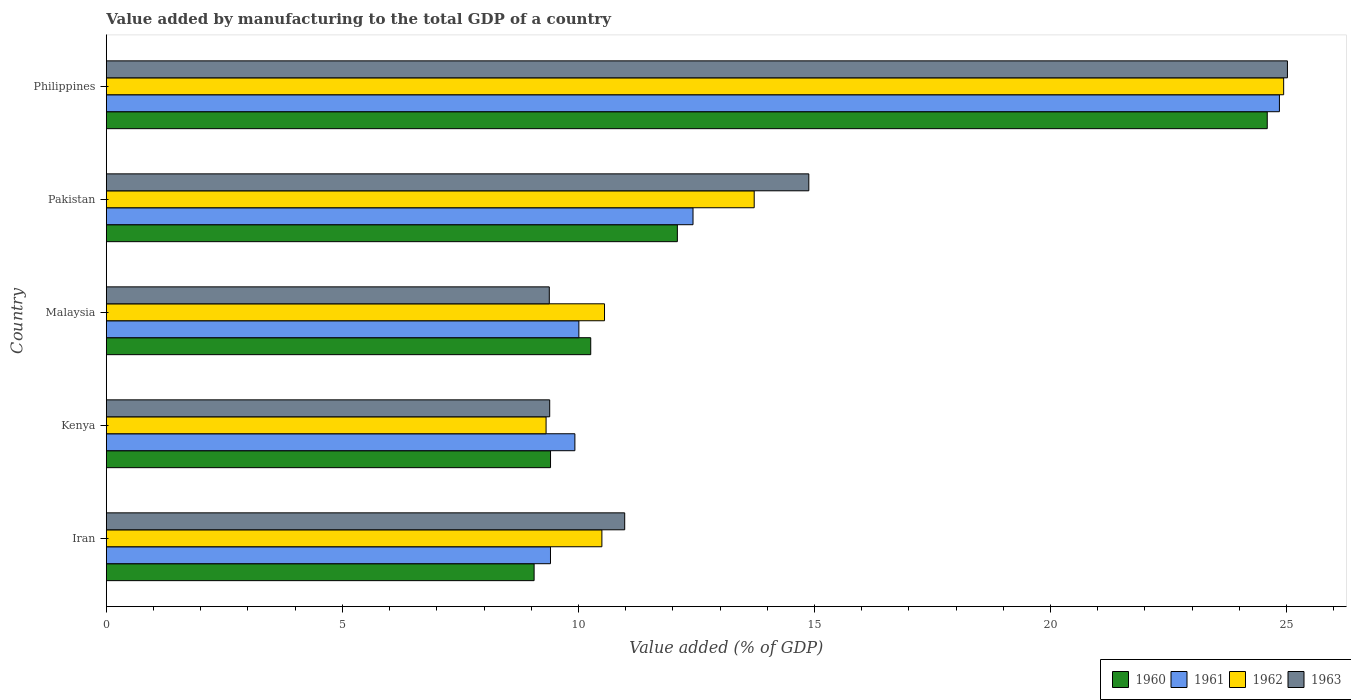How many different coloured bars are there?
Offer a very short reply. 4. How many groups of bars are there?
Your answer should be very brief. 5. Are the number of bars per tick equal to the number of legend labels?
Provide a succinct answer. Yes. How many bars are there on the 1st tick from the bottom?
Give a very brief answer. 4. What is the label of the 5th group of bars from the top?
Give a very brief answer. Iran. In how many cases, is the number of bars for a given country not equal to the number of legend labels?
Give a very brief answer. 0. What is the value added by manufacturing to the total GDP in 1963 in Malaysia?
Offer a very short reply. 9.38. Across all countries, what is the maximum value added by manufacturing to the total GDP in 1963?
Keep it short and to the point. 25.02. Across all countries, what is the minimum value added by manufacturing to the total GDP in 1960?
Offer a terse response. 9.06. In which country was the value added by manufacturing to the total GDP in 1960 maximum?
Give a very brief answer. Philippines. In which country was the value added by manufacturing to the total GDP in 1960 minimum?
Keep it short and to the point. Iran. What is the total value added by manufacturing to the total GDP in 1960 in the graph?
Your response must be concise. 65.42. What is the difference between the value added by manufacturing to the total GDP in 1960 in Kenya and that in Malaysia?
Your answer should be very brief. -0.85. What is the difference between the value added by manufacturing to the total GDP in 1961 in Kenya and the value added by manufacturing to the total GDP in 1962 in Pakistan?
Keep it short and to the point. -3.8. What is the average value added by manufacturing to the total GDP in 1960 per country?
Your response must be concise. 13.08. What is the difference between the value added by manufacturing to the total GDP in 1961 and value added by manufacturing to the total GDP in 1962 in Malaysia?
Your answer should be compact. -0.54. In how many countries, is the value added by manufacturing to the total GDP in 1963 greater than 20 %?
Your answer should be compact. 1. What is the ratio of the value added by manufacturing to the total GDP in 1963 in Iran to that in Pakistan?
Offer a very short reply. 0.74. What is the difference between the highest and the second highest value added by manufacturing to the total GDP in 1962?
Provide a short and direct response. 11.22. What is the difference between the highest and the lowest value added by manufacturing to the total GDP in 1960?
Offer a terse response. 15.53. What does the 2nd bar from the top in Iran represents?
Your answer should be very brief. 1962. What does the 2nd bar from the bottom in Kenya represents?
Your answer should be compact. 1961. Is it the case that in every country, the sum of the value added by manufacturing to the total GDP in 1960 and value added by manufacturing to the total GDP in 1962 is greater than the value added by manufacturing to the total GDP in 1963?
Give a very brief answer. Yes. How many bars are there?
Keep it short and to the point. 20. Are the values on the major ticks of X-axis written in scientific E-notation?
Keep it short and to the point. No. Does the graph contain any zero values?
Give a very brief answer. No. Does the graph contain grids?
Ensure brevity in your answer.  No. Where does the legend appear in the graph?
Provide a succinct answer. Bottom right. How many legend labels are there?
Offer a terse response. 4. What is the title of the graph?
Ensure brevity in your answer.  Value added by manufacturing to the total GDP of a country. What is the label or title of the X-axis?
Provide a short and direct response. Value added (% of GDP). What is the Value added (% of GDP) in 1960 in Iran?
Make the answer very short. 9.06. What is the Value added (% of GDP) of 1961 in Iran?
Your answer should be compact. 9.41. What is the Value added (% of GDP) of 1962 in Iran?
Your response must be concise. 10.5. What is the Value added (% of GDP) of 1963 in Iran?
Make the answer very short. 10.98. What is the Value added (% of GDP) in 1960 in Kenya?
Your answer should be compact. 9.41. What is the Value added (% of GDP) of 1961 in Kenya?
Your answer should be compact. 9.93. What is the Value added (% of GDP) of 1962 in Kenya?
Keep it short and to the point. 9.32. What is the Value added (% of GDP) of 1963 in Kenya?
Provide a short and direct response. 9.39. What is the Value added (% of GDP) of 1960 in Malaysia?
Give a very brief answer. 10.26. What is the Value added (% of GDP) of 1961 in Malaysia?
Provide a succinct answer. 10.01. What is the Value added (% of GDP) in 1962 in Malaysia?
Make the answer very short. 10.55. What is the Value added (% of GDP) of 1963 in Malaysia?
Provide a succinct answer. 9.38. What is the Value added (% of GDP) in 1960 in Pakistan?
Give a very brief answer. 12.1. What is the Value added (% of GDP) in 1961 in Pakistan?
Your response must be concise. 12.43. What is the Value added (% of GDP) of 1962 in Pakistan?
Offer a very short reply. 13.72. What is the Value added (% of GDP) in 1963 in Pakistan?
Your answer should be very brief. 14.88. What is the Value added (% of GDP) in 1960 in Philippines?
Your answer should be compact. 24.59. What is the Value added (% of GDP) of 1961 in Philippines?
Provide a succinct answer. 24.85. What is the Value added (% of GDP) of 1962 in Philippines?
Your response must be concise. 24.94. What is the Value added (% of GDP) of 1963 in Philippines?
Make the answer very short. 25.02. Across all countries, what is the maximum Value added (% of GDP) of 1960?
Make the answer very short. 24.59. Across all countries, what is the maximum Value added (% of GDP) of 1961?
Keep it short and to the point. 24.85. Across all countries, what is the maximum Value added (% of GDP) of 1962?
Offer a terse response. 24.94. Across all countries, what is the maximum Value added (% of GDP) in 1963?
Your answer should be compact. 25.02. Across all countries, what is the minimum Value added (% of GDP) of 1960?
Offer a terse response. 9.06. Across all countries, what is the minimum Value added (% of GDP) in 1961?
Your response must be concise. 9.41. Across all countries, what is the minimum Value added (% of GDP) in 1962?
Offer a very short reply. 9.32. Across all countries, what is the minimum Value added (% of GDP) of 1963?
Offer a very short reply. 9.38. What is the total Value added (% of GDP) in 1960 in the graph?
Give a very brief answer. 65.42. What is the total Value added (% of GDP) in 1961 in the graph?
Your response must be concise. 66.62. What is the total Value added (% of GDP) of 1962 in the graph?
Ensure brevity in your answer.  69.03. What is the total Value added (% of GDP) in 1963 in the graph?
Your answer should be very brief. 69.66. What is the difference between the Value added (% of GDP) in 1960 in Iran and that in Kenya?
Keep it short and to the point. -0.35. What is the difference between the Value added (% of GDP) in 1961 in Iran and that in Kenya?
Your answer should be very brief. -0.52. What is the difference between the Value added (% of GDP) in 1962 in Iran and that in Kenya?
Make the answer very short. 1.18. What is the difference between the Value added (% of GDP) in 1963 in Iran and that in Kenya?
Keep it short and to the point. 1.59. What is the difference between the Value added (% of GDP) of 1960 in Iran and that in Malaysia?
Provide a succinct answer. -1.2. What is the difference between the Value added (% of GDP) of 1961 in Iran and that in Malaysia?
Keep it short and to the point. -0.6. What is the difference between the Value added (% of GDP) in 1962 in Iran and that in Malaysia?
Your answer should be compact. -0.06. What is the difference between the Value added (% of GDP) in 1963 in Iran and that in Malaysia?
Your answer should be compact. 1.6. What is the difference between the Value added (% of GDP) of 1960 in Iran and that in Pakistan?
Offer a very short reply. -3.03. What is the difference between the Value added (% of GDP) in 1961 in Iran and that in Pakistan?
Provide a short and direct response. -3.02. What is the difference between the Value added (% of GDP) in 1962 in Iran and that in Pakistan?
Ensure brevity in your answer.  -3.23. What is the difference between the Value added (% of GDP) in 1963 in Iran and that in Pakistan?
Provide a short and direct response. -3.9. What is the difference between the Value added (% of GDP) in 1960 in Iran and that in Philippines?
Give a very brief answer. -15.53. What is the difference between the Value added (% of GDP) of 1961 in Iran and that in Philippines?
Your answer should be very brief. -15.44. What is the difference between the Value added (% of GDP) of 1962 in Iran and that in Philippines?
Ensure brevity in your answer.  -14.44. What is the difference between the Value added (% of GDP) of 1963 in Iran and that in Philippines?
Keep it short and to the point. -14.04. What is the difference between the Value added (% of GDP) in 1960 in Kenya and that in Malaysia?
Your answer should be very brief. -0.85. What is the difference between the Value added (% of GDP) in 1961 in Kenya and that in Malaysia?
Offer a very short reply. -0.08. What is the difference between the Value added (% of GDP) in 1962 in Kenya and that in Malaysia?
Keep it short and to the point. -1.24. What is the difference between the Value added (% of GDP) in 1963 in Kenya and that in Malaysia?
Ensure brevity in your answer.  0.01. What is the difference between the Value added (% of GDP) of 1960 in Kenya and that in Pakistan?
Keep it short and to the point. -2.69. What is the difference between the Value added (% of GDP) of 1961 in Kenya and that in Pakistan?
Offer a terse response. -2.5. What is the difference between the Value added (% of GDP) of 1962 in Kenya and that in Pakistan?
Provide a succinct answer. -4.41. What is the difference between the Value added (% of GDP) of 1963 in Kenya and that in Pakistan?
Offer a terse response. -5.49. What is the difference between the Value added (% of GDP) of 1960 in Kenya and that in Philippines?
Offer a terse response. -15.18. What is the difference between the Value added (% of GDP) of 1961 in Kenya and that in Philippines?
Provide a short and direct response. -14.92. What is the difference between the Value added (% of GDP) in 1962 in Kenya and that in Philippines?
Your response must be concise. -15.62. What is the difference between the Value added (% of GDP) of 1963 in Kenya and that in Philippines?
Offer a terse response. -15.63. What is the difference between the Value added (% of GDP) of 1960 in Malaysia and that in Pakistan?
Provide a succinct answer. -1.84. What is the difference between the Value added (% of GDP) of 1961 in Malaysia and that in Pakistan?
Your answer should be compact. -2.42. What is the difference between the Value added (% of GDP) in 1962 in Malaysia and that in Pakistan?
Ensure brevity in your answer.  -3.17. What is the difference between the Value added (% of GDP) in 1963 in Malaysia and that in Pakistan?
Provide a succinct answer. -5.5. What is the difference between the Value added (% of GDP) of 1960 in Malaysia and that in Philippines?
Your response must be concise. -14.33. What is the difference between the Value added (% of GDP) of 1961 in Malaysia and that in Philippines?
Your answer should be very brief. -14.84. What is the difference between the Value added (% of GDP) in 1962 in Malaysia and that in Philippines?
Your answer should be compact. -14.39. What is the difference between the Value added (% of GDP) in 1963 in Malaysia and that in Philippines?
Your answer should be compact. -15.64. What is the difference between the Value added (% of GDP) in 1960 in Pakistan and that in Philippines?
Provide a succinct answer. -12.5. What is the difference between the Value added (% of GDP) in 1961 in Pakistan and that in Philippines?
Offer a very short reply. -12.42. What is the difference between the Value added (% of GDP) in 1962 in Pakistan and that in Philippines?
Provide a succinct answer. -11.22. What is the difference between the Value added (% of GDP) in 1963 in Pakistan and that in Philippines?
Ensure brevity in your answer.  -10.14. What is the difference between the Value added (% of GDP) in 1960 in Iran and the Value added (% of GDP) in 1961 in Kenya?
Offer a terse response. -0.86. What is the difference between the Value added (% of GDP) in 1960 in Iran and the Value added (% of GDP) in 1962 in Kenya?
Ensure brevity in your answer.  -0.25. What is the difference between the Value added (% of GDP) of 1960 in Iran and the Value added (% of GDP) of 1963 in Kenya?
Ensure brevity in your answer.  -0.33. What is the difference between the Value added (% of GDP) of 1961 in Iran and the Value added (% of GDP) of 1962 in Kenya?
Ensure brevity in your answer.  0.09. What is the difference between the Value added (% of GDP) of 1961 in Iran and the Value added (% of GDP) of 1963 in Kenya?
Make the answer very short. 0.02. What is the difference between the Value added (% of GDP) in 1962 in Iran and the Value added (% of GDP) in 1963 in Kenya?
Your response must be concise. 1.11. What is the difference between the Value added (% of GDP) in 1960 in Iran and the Value added (% of GDP) in 1961 in Malaysia?
Ensure brevity in your answer.  -0.95. What is the difference between the Value added (% of GDP) of 1960 in Iran and the Value added (% of GDP) of 1962 in Malaysia?
Provide a succinct answer. -1.49. What is the difference between the Value added (% of GDP) of 1960 in Iran and the Value added (% of GDP) of 1963 in Malaysia?
Offer a terse response. -0.32. What is the difference between the Value added (% of GDP) in 1961 in Iran and the Value added (% of GDP) in 1962 in Malaysia?
Your answer should be very brief. -1.14. What is the difference between the Value added (% of GDP) in 1961 in Iran and the Value added (% of GDP) in 1963 in Malaysia?
Provide a succinct answer. 0.03. What is the difference between the Value added (% of GDP) in 1962 in Iran and the Value added (% of GDP) in 1963 in Malaysia?
Your answer should be compact. 1.11. What is the difference between the Value added (% of GDP) in 1960 in Iran and the Value added (% of GDP) in 1961 in Pakistan?
Ensure brevity in your answer.  -3.37. What is the difference between the Value added (% of GDP) of 1960 in Iran and the Value added (% of GDP) of 1962 in Pakistan?
Provide a succinct answer. -4.66. What is the difference between the Value added (% of GDP) of 1960 in Iran and the Value added (% of GDP) of 1963 in Pakistan?
Provide a succinct answer. -5.82. What is the difference between the Value added (% of GDP) of 1961 in Iran and the Value added (% of GDP) of 1962 in Pakistan?
Provide a short and direct response. -4.32. What is the difference between the Value added (% of GDP) in 1961 in Iran and the Value added (% of GDP) in 1963 in Pakistan?
Your response must be concise. -5.47. What is the difference between the Value added (% of GDP) of 1962 in Iran and the Value added (% of GDP) of 1963 in Pakistan?
Make the answer very short. -4.38. What is the difference between the Value added (% of GDP) of 1960 in Iran and the Value added (% of GDP) of 1961 in Philippines?
Keep it short and to the point. -15.79. What is the difference between the Value added (% of GDP) of 1960 in Iran and the Value added (% of GDP) of 1962 in Philippines?
Your answer should be very brief. -15.88. What is the difference between the Value added (% of GDP) of 1960 in Iran and the Value added (% of GDP) of 1963 in Philippines?
Ensure brevity in your answer.  -15.96. What is the difference between the Value added (% of GDP) in 1961 in Iran and the Value added (% of GDP) in 1962 in Philippines?
Your answer should be compact. -15.53. What is the difference between the Value added (% of GDP) in 1961 in Iran and the Value added (% of GDP) in 1963 in Philippines?
Provide a short and direct response. -15.61. What is the difference between the Value added (% of GDP) of 1962 in Iran and the Value added (% of GDP) of 1963 in Philippines?
Keep it short and to the point. -14.52. What is the difference between the Value added (% of GDP) of 1960 in Kenya and the Value added (% of GDP) of 1961 in Malaysia?
Offer a very short reply. -0.6. What is the difference between the Value added (% of GDP) in 1960 in Kenya and the Value added (% of GDP) in 1962 in Malaysia?
Offer a terse response. -1.14. What is the difference between the Value added (% of GDP) of 1960 in Kenya and the Value added (% of GDP) of 1963 in Malaysia?
Your answer should be compact. 0.03. What is the difference between the Value added (% of GDP) of 1961 in Kenya and the Value added (% of GDP) of 1962 in Malaysia?
Provide a short and direct response. -0.63. What is the difference between the Value added (% of GDP) in 1961 in Kenya and the Value added (% of GDP) in 1963 in Malaysia?
Your response must be concise. 0.54. What is the difference between the Value added (% of GDP) of 1962 in Kenya and the Value added (% of GDP) of 1963 in Malaysia?
Give a very brief answer. -0.07. What is the difference between the Value added (% of GDP) in 1960 in Kenya and the Value added (% of GDP) in 1961 in Pakistan?
Give a very brief answer. -3.02. What is the difference between the Value added (% of GDP) of 1960 in Kenya and the Value added (% of GDP) of 1962 in Pakistan?
Offer a terse response. -4.31. What is the difference between the Value added (% of GDP) of 1960 in Kenya and the Value added (% of GDP) of 1963 in Pakistan?
Provide a short and direct response. -5.47. What is the difference between the Value added (% of GDP) in 1961 in Kenya and the Value added (% of GDP) in 1962 in Pakistan?
Your response must be concise. -3.8. What is the difference between the Value added (% of GDP) in 1961 in Kenya and the Value added (% of GDP) in 1963 in Pakistan?
Your response must be concise. -4.96. What is the difference between the Value added (% of GDP) in 1962 in Kenya and the Value added (% of GDP) in 1963 in Pakistan?
Provide a short and direct response. -5.57. What is the difference between the Value added (% of GDP) of 1960 in Kenya and the Value added (% of GDP) of 1961 in Philippines?
Your answer should be very brief. -15.44. What is the difference between the Value added (% of GDP) of 1960 in Kenya and the Value added (% of GDP) of 1962 in Philippines?
Give a very brief answer. -15.53. What is the difference between the Value added (% of GDP) of 1960 in Kenya and the Value added (% of GDP) of 1963 in Philippines?
Make the answer very short. -15.61. What is the difference between the Value added (% of GDP) of 1961 in Kenya and the Value added (% of GDP) of 1962 in Philippines?
Make the answer very short. -15.01. What is the difference between the Value added (% of GDP) of 1961 in Kenya and the Value added (% of GDP) of 1963 in Philippines?
Your response must be concise. -15.09. What is the difference between the Value added (% of GDP) of 1962 in Kenya and the Value added (% of GDP) of 1963 in Philippines?
Provide a short and direct response. -15.7. What is the difference between the Value added (% of GDP) in 1960 in Malaysia and the Value added (% of GDP) in 1961 in Pakistan?
Provide a short and direct response. -2.17. What is the difference between the Value added (% of GDP) in 1960 in Malaysia and the Value added (% of GDP) in 1962 in Pakistan?
Ensure brevity in your answer.  -3.46. What is the difference between the Value added (% of GDP) in 1960 in Malaysia and the Value added (% of GDP) in 1963 in Pakistan?
Keep it short and to the point. -4.62. What is the difference between the Value added (% of GDP) of 1961 in Malaysia and the Value added (% of GDP) of 1962 in Pakistan?
Give a very brief answer. -3.71. What is the difference between the Value added (% of GDP) of 1961 in Malaysia and the Value added (% of GDP) of 1963 in Pakistan?
Provide a short and direct response. -4.87. What is the difference between the Value added (% of GDP) of 1962 in Malaysia and the Value added (% of GDP) of 1963 in Pakistan?
Provide a succinct answer. -4.33. What is the difference between the Value added (% of GDP) in 1960 in Malaysia and the Value added (% of GDP) in 1961 in Philippines?
Give a very brief answer. -14.59. What is the difference between the Value added (% of GDP) of 1960 in Malaysia and the Value added (% of GDP) of 1962 in Philippines?
Provide a short and direct response. -14.68. What is the difference between the Value added (% of GDP) in 1960 in Malaysia and the Value added (% of GDP) in 1963 in Philippines?
Offer a very short reply. -14.76. What is the difference between the Value added (% of GDP) of 1961 in Malaysia and the Value added (% of GDP) of 1962 in Philippines?
Provide a succinct answer. -14.93. What is the difference between the Value added (% of GDP) of 1961 in Malaysia and the Value added (% of GDP) of 1963 in Philippines?
Offer a terse response. -15.01. What is the difference between the Value added (% of GDP) of 1962 in Malaysia and the Value added (% of GDP) of 1963 in Philippines?
Make the answer very short. -14.47. What is the difference between the Value added (% of GDP) in 1960 in Pakistan and the Value added (% of GDP) in 1961 in Philippines?
Make the answer very short. -12.75. What is the difference between the Value added (% of GDP) in 1960 in Pakistan and the Value added (% of GDP) in 1962 in Philippines?
Make the answer very short. -12.84. What is the difference between the Value added (% of GDP) of 1960 in Pakistan and the Value added (% of GDP) of 1963 in Philippines?
Your answer should be compact. -12.92. What is the difference between the Value added (% of GDP) in 1961 in Pakistan and the Value added (% of GDP) in 1962 in Philippines?
Keep it short and to the point. -12.51. What is the difference between the Value added (% of GDP) of 1961 in Pakistan and the Value added (% of GDP) of 1963 in Philippines?
Offer a terse response. -12.59. What is the difference between the Value added (% of GDP) of 1962 in Pakistan and the Value added (% of GDP) of 1963 in Philippines?
Make the answer very short. -11.3. What is the average Value added (% of GDP) of 1960 per country?
Offer a very short reply. 13.08. What is the average Value added (% of GDP) in 1961 per country?
Provide a succinct answer. 13.32. What is the average Value added (% of GDP) of 1962 per country?
Make the answer very short. 13.81. What is the average Value added (% of GDP) in 1963 per country?
Provide a short and direct response. 13.93. What is the difference between the Value added (% of GDP) in 1960 and Value added (% of GDP) in 1961 in Iran?
Provide a short and direct response. -0.35. What is the difference between the Value added (% of GDP) of 1960 and Value added (% of GDP) of 1962 in Iran?
Provide a succinct answer. -1.44. What is the difference between the Value added (% of GDP) of 1960 and Value added (% of GDP) of 1963 in Iran?
Provide a short and direct response. -1.92. What is the difference between the Value added (% of GDP) of 1961 and Value added (% of GDP) of 1962 in Iran?
Keep it short and to the point. -1.09. What is the difference between the Value added (% of GDP) in 1961 and Value added (% of GDP) in 1963 in Iran?
Your answer should be compact. -1.57. What is the difference between the Value added (% of GDP) in 1962 and Value added (% of GDP) in 1963 in Iran?
Ensure brevity in your answer.  -0.48. What is the difference between the Value added (% of GDP) of 1960 and Value added (% of GDP) of 1961 in Kenya?
Ensure brevity in your answer.  -0.52. What is the difference between the Value added (% of GDP) in 1960 and Value added (% of GDP) in 1962 in Kenya?
Provide a short and direct response. 0.09. What is the difference between the Value added (% of GDP) of 1960 and Value added (% of GDP) of 1963 in Kenya?
Ensure brevity in your answer.  0.02. What is the difference between the Value added (% of GDP) in 1961 and Value added (% of GDP) in 1962 in Kenya?
Provide a short and direct response. 0.61. What is the difference between the Value added (% of GDP) of 1961 and Value added (% of GDP) of 1963 in Kenya?
Offer a very short reply. 0.53. What is the difference between the Value added (% of GDP) in 1962 and Value added (% of GDP) in 1963 in Kenya?
Offer a very short reply. -0.08. What is the difference between the Value added (% of GDP) of 1960 and Value added (% of GDP) of 1961 in Malaysia?
Provide a succinct answer. 0.25. What is the difference between the Value added (% of GDP) of 1960 and Value added (% of GDP) of 1962 in Malaysia?
Your response must be concise. -0.29. What is the difference between the Value added (% of GDP) in 1960 and Value added (% of GDP) in 1963 in Malaysia?
Ensure brevity in your answer.  0.88. What is the difference between the Value added (% of GDP) in 1961 and Value added (% of GDP) in 1962 in Malaysia?
Your answer should be compact. -0.54. What is the difference between the Value added (% of GDP) of 1961 and Value added (% of GDP) of 1963 in Malaysia?
Your response must be concise. 0.63. What is the difference between the Value added (% of GDP) in 1962 and Value added (% of GDP) in 1963 in Malaysia?
Ensure brevity in your answer.  1.17. What is the difference between the Value added (% of GDP) of 1960 and Value added (% of GDP) of 1961 in Pakistan?
Provide a succinct answer. -0.33. What is the difference between the Value added (% of GDP) of 1960 and Value added (% of GDP) of 1962 in Pakistan?
Provide a short and direct response. -1.63. What is the difference between the Value added (% of GDP) of 1960 and Value added (% of GDP) of 1963 in Pakistan?
Provide a succinct answer. -2.78. What is the difference between the Value added (% of GDP) in 1961 and Value added (% of GDP) in 1962 in Pakistan?
Your answer should be compact. -1.3. What is the difference between the Value added (% of GDP) of 1961 and Value added (% of GDP) of 1963 in Pakistan?
Provide a succinct answer. -2.45. What is the difference between the Value added (% of GDP) of 1962 and Value added (% of GDP) of 1963 in Pakistan?
Your response must be concise. -1.16. What is the difference between the Value added (% of GDP) in 1960 and Value added (% of GDP) in 1961 in Philippines?
Your response must be concise. -0.26. What is the difference between the Value added (% of GDP) in 1960 and Value added (% of GDP) in 1962 in Philippines?
Offer a very short reply. -0.35. What is the difference between the Value added (% of GDP) in 1960 and Value added (% of GDP) in 1963 in Philippines?
Provide a short and direct response. -0.43. What is the difference between the Value added (% of GDP) of 1961 and Value added (% of GDP) of 1962 in Philippines?
Your response must be concise. -0.09. What is the difference between the Value added (% of GDP) in 1961 and Value added (% of GDP) in 1963 in Philippines?
Offer a terse response. -0.17. What is the difference between the Value added (% of GDP) of 1962 and Value added (% of GDP) of 1963 in Philippines?
Make the answer very short. -0.08. What is the ratio of the Value added (% of GDP) in 1961 in Iran to that in Kenya?
Offer a very short reply. 0.95. What is the ratio of the Value added (% of GDP) in 1962 in Iran to that in Kenya?
Ensure brevity in your answer.  1.13. What is the ratio of the Value added (% of GDP) of 1963 in Iran to that in Kenya?
Offer a very short reply. 1.17. What is the ratio of the Value added (% of GDP) in 1960 in Iran to that in Malaysia?
Provide a short and direct response. 0.88. What is the ratio of the Value added (% of GDP) in 1961 in Iran to that in Malaysia?
Provide a short and direct response. 0.94. What is the ratio of the Value added (% of GDP) in 1962 in Iran to that in Malaysia?
Keep it short and to the point. 0.99. What is the ratio of the Value added (% of GDP) in 1963 in Iran to that in Malaysia?
Your answer should be compact. 1.17. What is the ratio of the Value added (% of GDP) of 1960 in Iran to that in Pakistan?
Your answer should be compact. 0.75. What is the ratio of the Value added (% of GDP) of 1961 in Iran to that in Pakistan?
Provide a short and direct response. 0.76. What is the ratio of the Value added (% of GDP) of 1962 in Iran to that in Pakistan?
Your answer should be very brief. 0.76. What is the ratio of the Value added (% of GDP) in 1963 in Iran to that in Pakistan?
Your answer should be compact. 0.74. What is the ratio of the Value added (% of GDP) in 1960 in Iran to that in Philippines?
Give a very brief answer. 0.37. What is the ratio of the Value added (% of GDP) of 1961 in Iran to that in Philippines?
Make the answer very short. 0.38. What is the ratio of the Value added (% of GDP) in 1962 in Iran to that in Philippines?
Give a very brief answer. 0.42. What is the ratio of the Value added (% of GDP) of 1963 in Iran to that in Philippines?
Your answer should be very brief. 0.44. What is the ratio of the Value added (% of GDP) of 1960 in Kenya to that in Malaysia?
Provide a succinct answer. 0.92. What is the ratio of the Value added (% of GDP) in 1961 in Kenya to that in Malaysia?
Give a very brief answer. 0.99. What is the ratio of the Value added (% of GDP) of 1962 in Kenya to that in Malaysia?
Your answer should be compact. 0.88. What is the ratio of the Value added (% of GDP) in 1960 in Kenya to that in Pakistan?
Keep it short and to the point. 0.78. What is the ratio of the Value added (% of GDP) of 1961 in Kenya to that in Pakistan?
Offer a very short reply. 0.8. What is the ratio of the Value added (% of GDP) of 1962 in Kenya to that in Pakistan?
Make the answer very short. 0.68. What is the ratio of the Value added (% of GDP) of 1963 in Kenya to that in Pakistan?
Provide a succinct answer. 0.63. What is the ratio of the Value added (% of GDP) in 1960 in Kenya to that in Philippines?
Offer a terse response. 0.38. What is the ratio of the Value added (% of GDP) in 1961 in Kenya to that in Philippines?
Your answer should be very brief. 0.4. What is the ratio of the Value added (% of GDP) in 1962 in Kenya to that in Philippines?
Offer a terse response. 0.37. What is the ratio of the Value added (% of GDP) in 1963 in Kenya to that in Philippines?
Provide a succinct answer. 0.38. What is the ratio of the Value added (% of GDP) of 1960 in Malaysia to that in Pakistan?
Offer a very short reply. 0.85. What is the ratio of the Value added (% of GDP) in 1961 in Malaysia to that in Pakistan?
Your response must be concise. 0.81. What is the ratio of the Value added (% of GDP) in 1962 in Malaysia to that in Pakistan?
Ensure brevity in your answer.  0.77. What is the ratio of the Value added (% of GDP) of 1963 in Malaysia to that in Pakistan?
Ensure brevity in your answer.  0.63. What is the ratio of the Value added (% of GDP) of 1960 in Malaysia to that in Philippines?
Your answer should be very brief. 0.42. What is the ratio of the Value added (% of GDP) of 1961 in Malaysia to that in Philippines?
Your response must be concise. 0.4. What is the ratio of the Value added (% of GDP) of 1962 in Malaysia to that in Philippines?
Give a very brief answer. 0.42. What is the ratio of the Value added (% of GDP) of 1960 in Pakistan to that in Philippines?
Keep it short and to the point. 0.49. What is the ratio of the Value added (% of GDP) in 1961 in Pakistan to that in Philippines?
Your answer should be very brief. 0.5. What is the ratio of the Value added (% of GDP) of 1962 in Pakistan to that in Philippines?
Your answer should be compact. 0.55. What is the ratio of the Value added (% of GDP) in 1963 in Pakistan to that in Philippines?
Make the answer very short. 0.59. What is the difference between the highest and the second highest Value added (% of GDP) in 1960?
Ensure brevity in your answer.  12.5. What is the difference between the highest and the second highest Value added (% of GDP) of 1961?
Make the answer very short. 12.42. What is the difference between the highest and the second highest Value added (% of GDP) in 1962?
Give a very brief answer. 11.22. What is the difference between the highest and the second highest Value added (% of GDP) in 1963?
Provide a short and direct response. 10.14. What is the difference between the highest and the lowest Value added (% of GDP) in 1960?
Your response must be concise. 15.53. What is the difference between the highest and the lowest Value added (% of GDP) in 1961?
Your answer should be compact. 15.44. What is the difference between the highest and the lowest Value added (% of GDP) in 1962?
Give a very brief answer. 15.62. What is the difference between the highest and the lowest Value added (% of GDP) of 1963?
Provide a short and direct response. 15.64. 